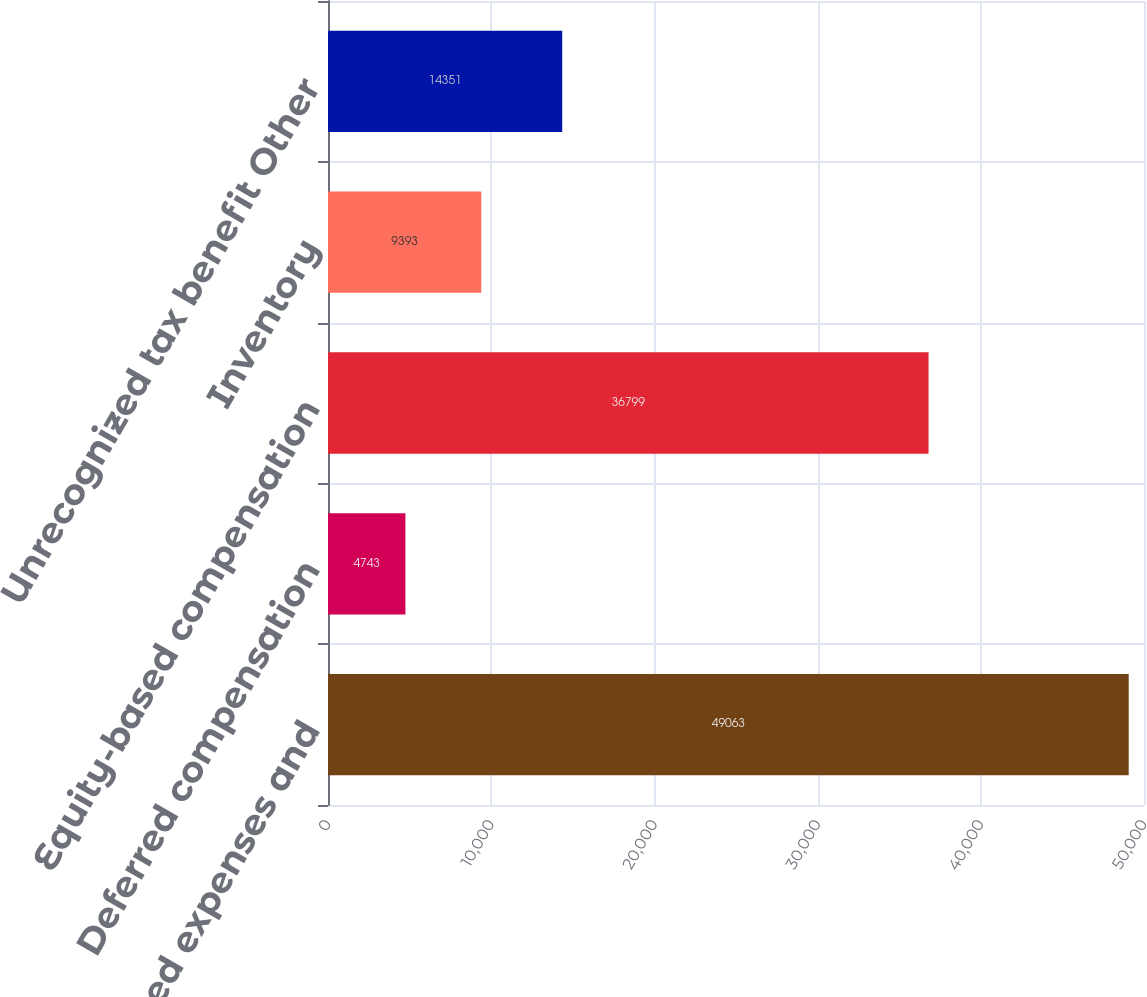<chart> <loc_0><loc_0><loc_500><loc_500><bar_chart><fcel>Other accrued expenses and<fcel>Deferred compensation<fcel>Equity-based compensation<fcel>Inventory<fcel>Unrecognized tax benefit Other<nl><fcel>49063<fcel>4743<fcel>36799<fcel>9393<fcel>14351<nl></chart> 